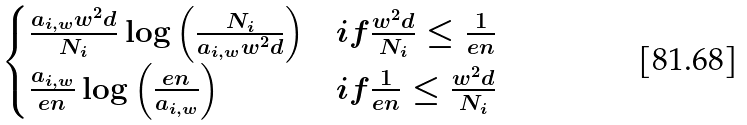<formula> <loc_0><loc_0><loc_500><loc_500>\begin{cases} \frac { a _ { i , w } w ^ { 2 } d } { N _ { i } } \log \left ( \frac { N _ { i } } { a _ { i , w } w ^ { 2 } d } \right ) & i f \frac { w ^ { 2 } d } { N _ { i } } \leq \frac { 1 } { e n } \\ \frac { a _ { i , w } } { e n } \log \left ( \frac { e n } { a _ { i , w } } \right ) & i f \frac { 1 } { e n } \leq \frac { w ^ { 2 } d } { N _ { i } } \end{cases}</formula> 